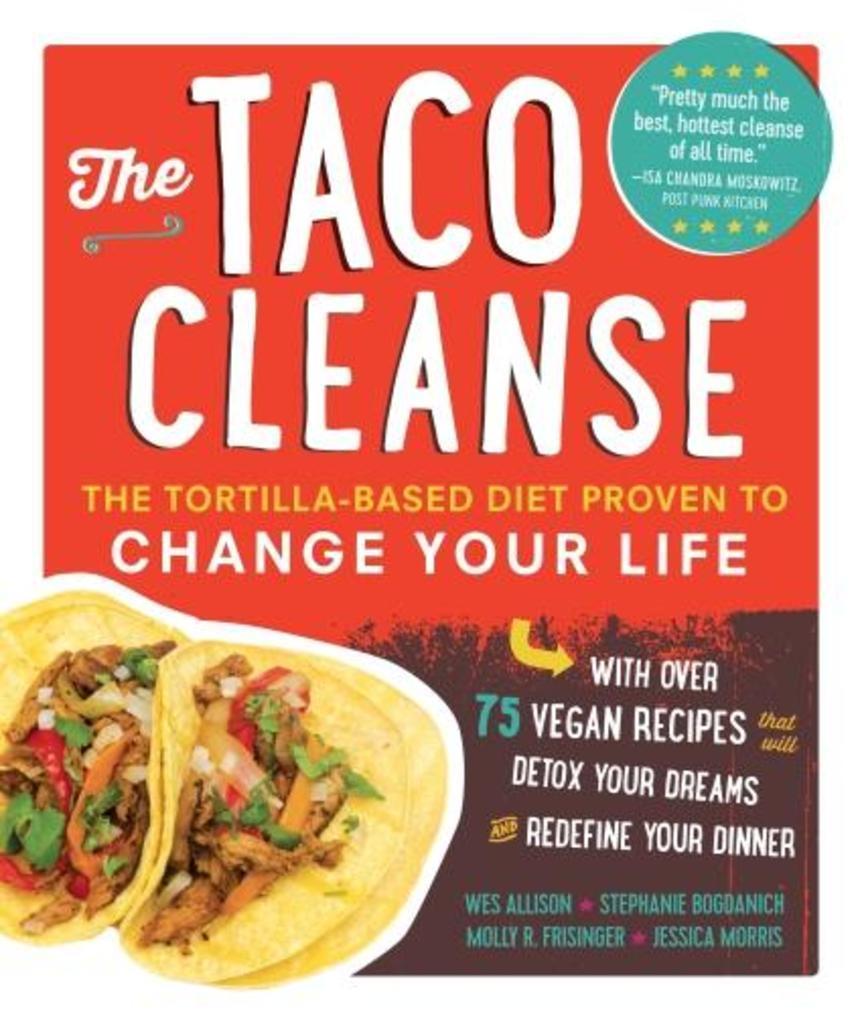Please provide a concise description of this image. It is a picture of a poster. We can see images and something is written on the poster. 